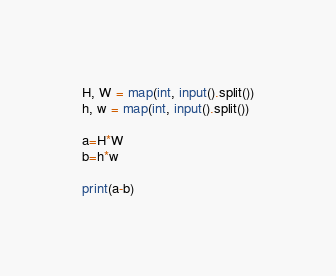<code> <loc_0><loc_0><loc_500><loc_500><_Python_>H, W = map(int, input().split())
h, w = map(int, input().split())

a=H*W
b=h*w

print(a-b)

</code> 